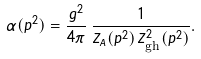<formula> <loc_0><loc_0><loc_500><loc_500>\alpha ( p ^ { 2 } ) = \frac { g ^ { 2 } } { 4 \pi } \, \frac { 1 } { Z _ { A } ( p ^ { 2 } ) \, Z _ { \text {gh} } ^ { 2 } ( p ^ { 2 } ) } .</formula> 